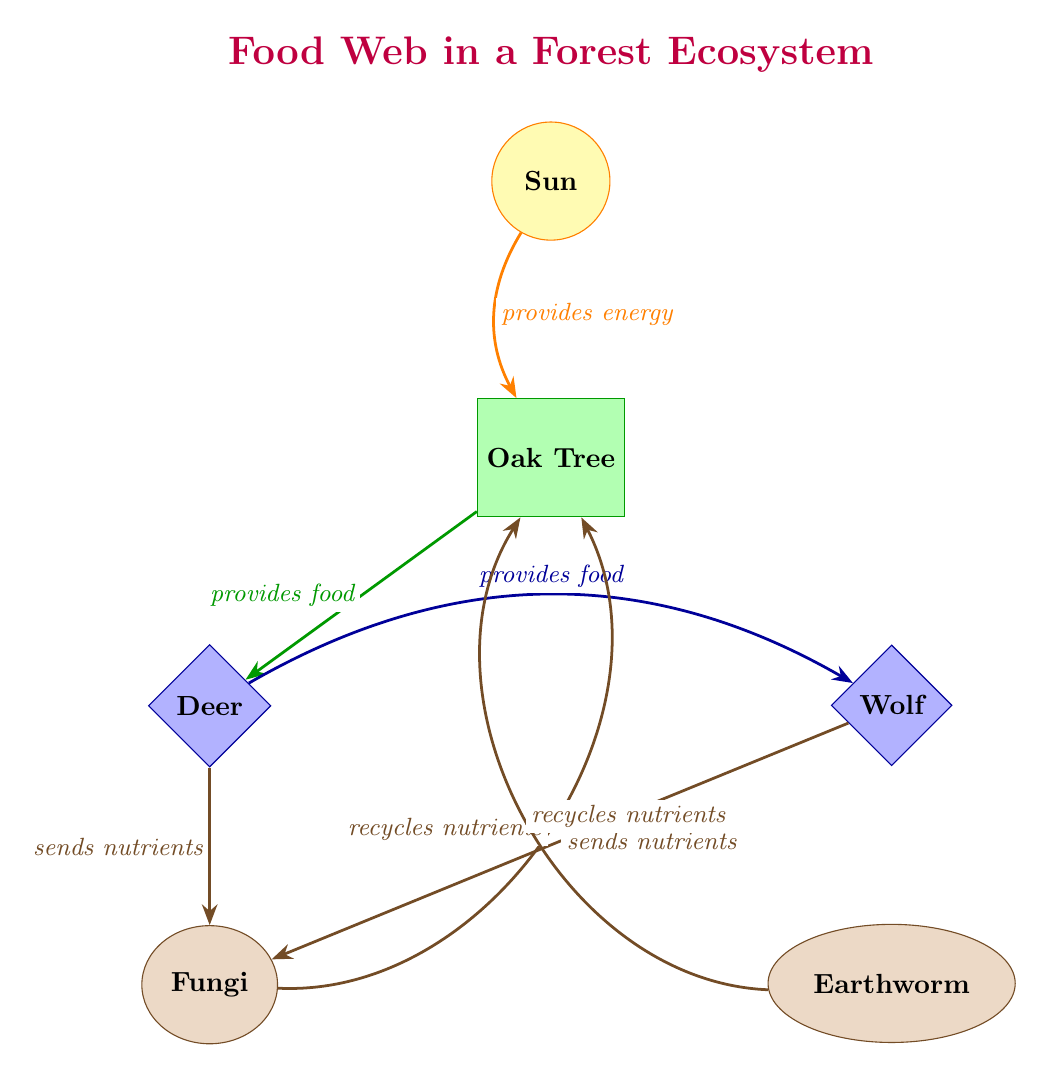What is the primary energy source in this food web? The diagram identifies the "Sun" as the central energy source by labeling it with the style "energy source." The arrow pointing from the Sun to the Oak Tree indicates that the Sun provides energy to the producer, reinforcing its role as the primary energy source.
Answer: Sun How many producers are present in the diagram? By analyzing the diagram, we can see there is only one producer depicted, which is the "Oak Tree." The shape and label confirm it as a producer within the food web, and no other producers are indicated.
Answer: 1 What do deer eat in this ecosystem? The diagram shows that the "Deer" consumes energy from the "Oak Tree," which is indicated by the arrow labeled "provides food." The flow of energy from the producer to the consumer clarifies that the deer feed on the oak tree.
Answer: Oak Tree Who sends nutrients to fungi? The diagram presents two arrows leading to "Fungi," one from "Deer" and another from "Wolf." Each arrow is labeled "sends nutrients," indicating that both consumers contribute nutrients to the decomposer.
Answer: Deer and Wolf What role do decomposers play in the food web? The arrows coming from both the "Deer" and the "Wolf" point to "Fungi," which illustrate that decomposers such as fungi recycle nutrients back into the ecosystem. This essential role helps maintain nutrient flow and soil health.
Answer: Recycle nutrients 